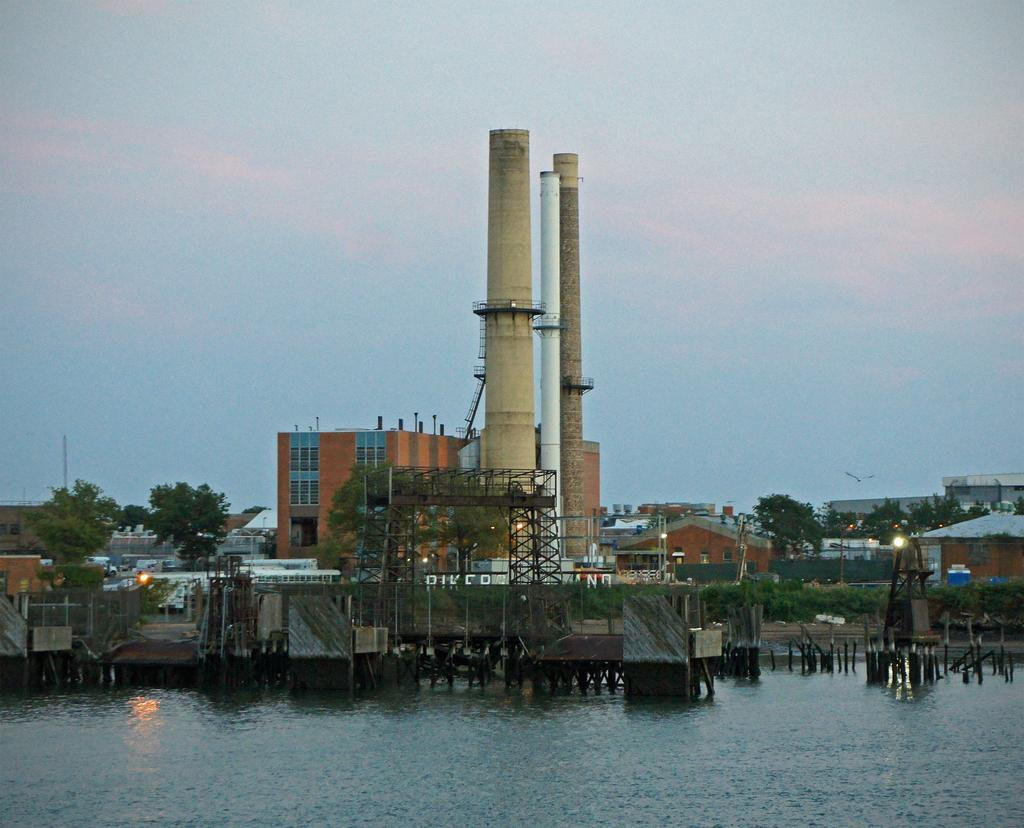What type of structures can be seen in the image? There are buildings in the image. What architectural feature is present in the image? Railings are present in the image. What is a prominent feature of the buildings in the image? There is a staircase in the image. What type of material is used for the grills in the image? Iron grills are visible in the image. What is a functional element of the buildings in the image? Chimneys are present in the image. What natural element is visible in the image? Water is visible in the image. What type of vegetation is present in the image? Trees are present in the image. What is visible in the background of the image? The sky is visible in the background of the image. What type of organization is depicted in the image? There is no organization depicted in the image; it features buildings, railings, a staircase, iron grills, chimneys, water, trees, and the sky. What shape is the lead in the image? There is no lead present in the image. 